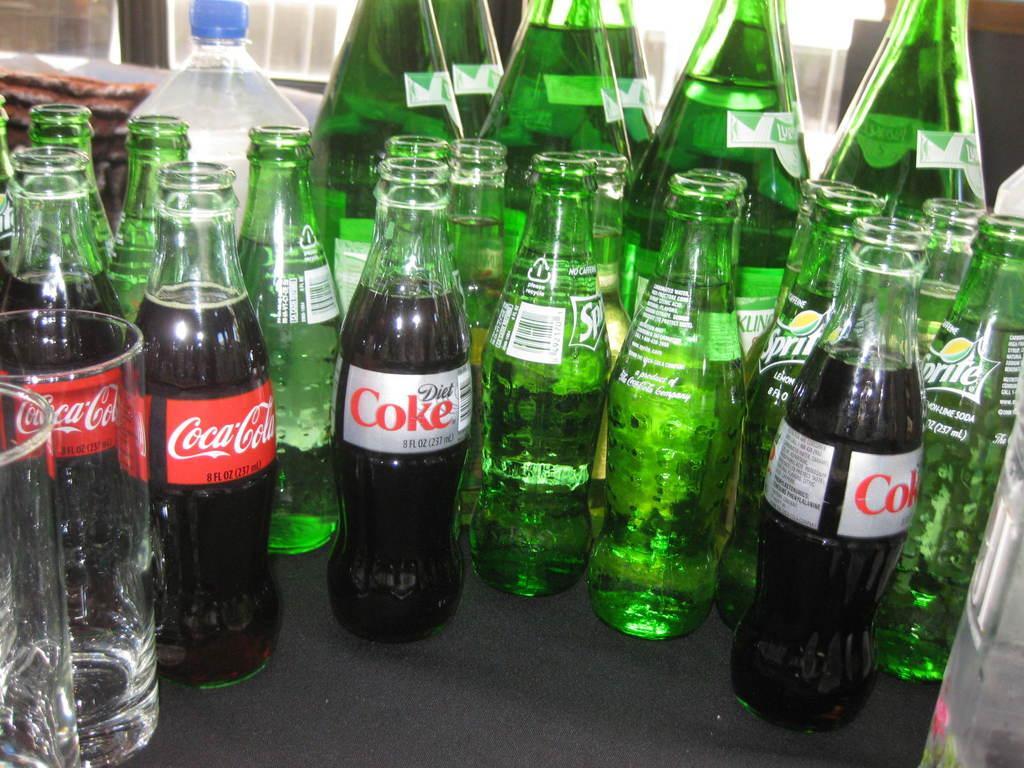How would you summarize this image in a sentence or two? In this picture there are some different kinds of drinks and bottles were placed on the table. There are two glasses in the left side of the image. 